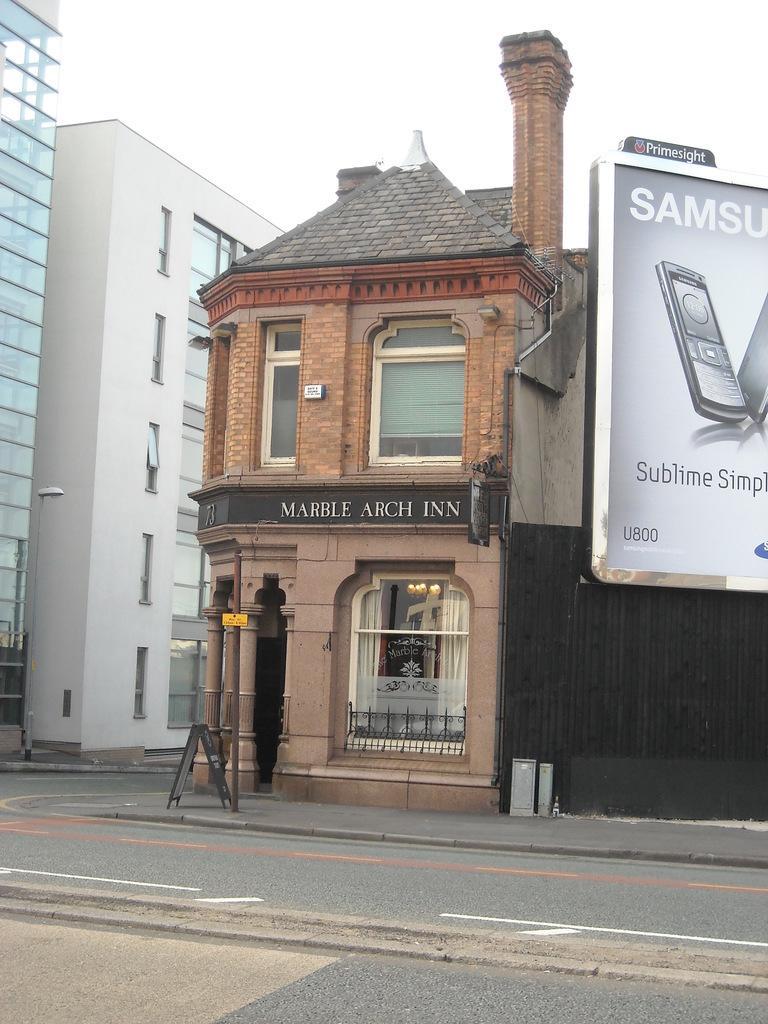How would you summarize this image in a sentence or two? In this picture we can see a hoarding. On the left side of the hoarding there are buildings and poles. On the building there is a name board and in front of the building there is a board and some objects. Behind the buildings there is the sky. 